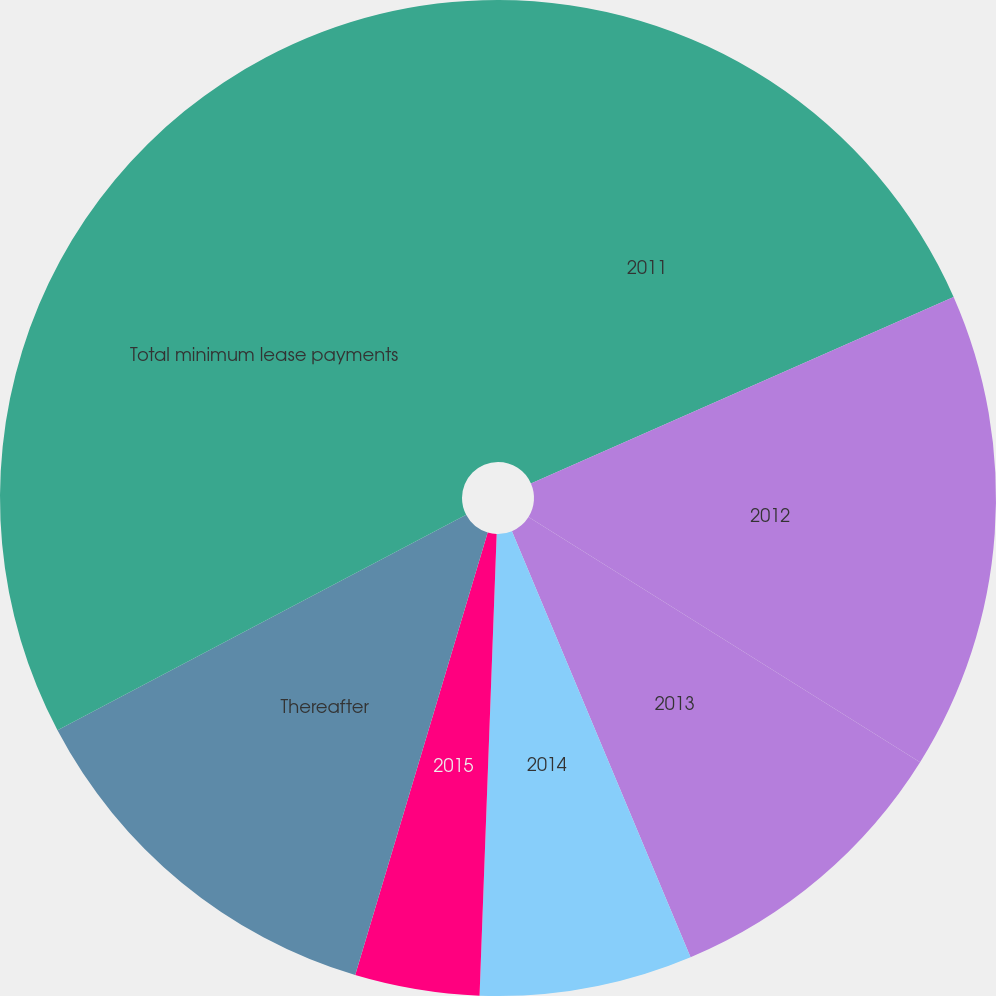Convert chart. <chart><loc_0><loc_0><loc_500><loc_500><pie_chart><fcel>2011<fcel>2012<fcel>2013<fcel>2014<fcel>2015<fcel>Thereafter<fcel>Total minimum lease payments<nl><fcel>18.39%<fcel>15.52%<fcel>9.78%<fcel>6.91%<fcel>4.04%<fcel>12.65%<fcel>32.73%<nl></chart> 